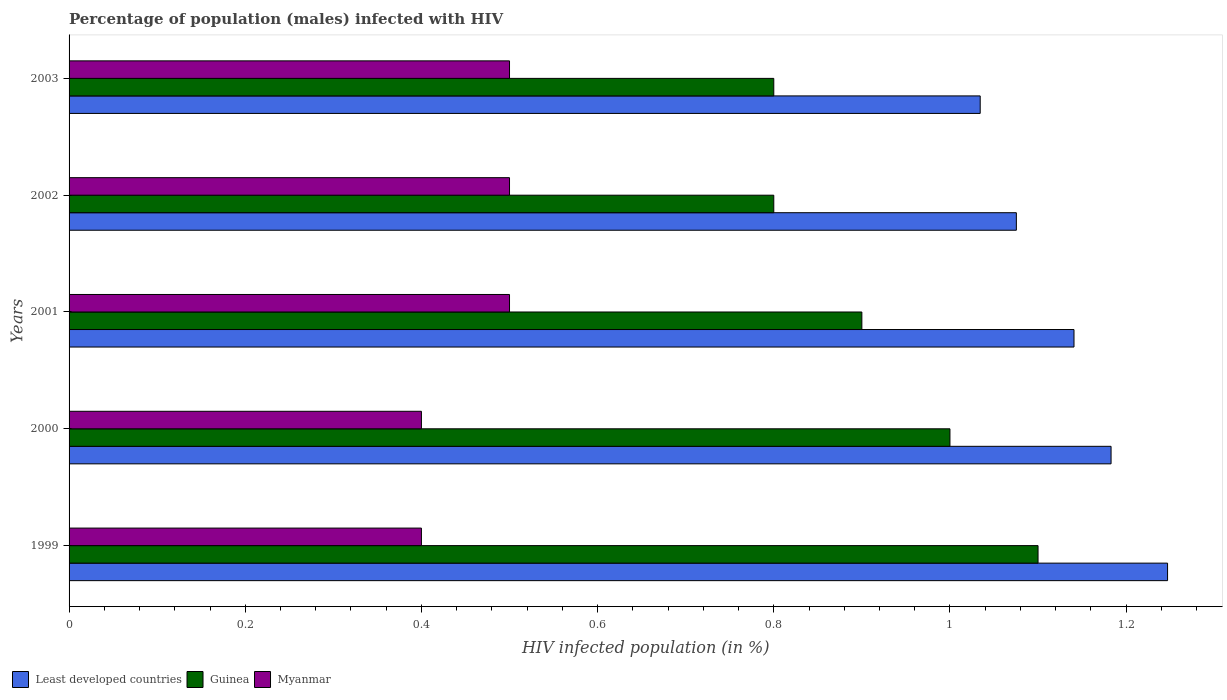Are the number of bars on each tick of the Y-axis equal?
Ensure brevity in your answer.  Yes. How many bars are there on the 2nd tick from the top?
Keep it short and to the point. 3. How many bars are there on the 4th tick from the bottom?
Give a very brief answer. 3. What is the label of the 2nd group of bars from the top?
Provide a short and direct response. 2002. What is the percentage of HIV infected male population in Least developed countries in 2000?
Your answer should be compact. 1.18. Across all years, what is the maximum percentage of HIV infected male population in Myanmar?
Ensure brevity in your answer.  0.5. What is the difference between the percentage of HIV infected male population in Least developed countries in 2002 and that in 2003?
Give a very brief answer. 0.04. What is the difference between the percentage of HIV infected male population in Myanmar in 2000 and the percentage of HIV infected male population in Guinea in 1999?
Offer a terse response. -0.7. What is the average percentage of HIV infected male population in Guinea per year?
Your response must be concise. 0.92. In the year 2002, what is the difference between the percentage of HIV infected male population in Myanmar and percentage of HIV infected male population in Guinea?
Your answer should be very brief. -0.3. What is the ratio of the percentage of HIV infected male population in Myanmar in 1999 to that in 2000?
Offer a very short reply. 1. What is the difference between the highest and the second highest percentage of HIV infected male population in Guinea?
Ensure brevity in your answer.  0.1. What is the difference between the highest and the lowest percentage of HIV infected male population in Guinea?
Offer a very short reply. 0.3. In how many years, is the percentage of HIV infected male population in Least developed countries greater than the average percentage of HIV infected male population in Least developed countries taken over all years?
Offer a very short reply. 3. Is the sum of the percentage of HIV infected male population in Least developed countries in 2000 and 2003 greater than the maximum percentage of HIV infected male population in Guinea across all years?
Make the answer very short. Yes. What does the 3rd bar from the top in 2003 represents?
Your response must be concise. Least developed countries. What does the 2nd bar from the bottom in 2003 represents?
Make the answer very short. Guinea. Is it the case that in every year, the sum of the percentage of HIV infected male population in Guinea and percentage of HIV infected male population in Least developed countries is greater than the percentage of HIV infected male population in Myanmar?
Offer a terse response. Yes. Are all the bars in the graph horizontal?
Keep it short and to the point. Yes. How many years are there in the graph?
Your answer should be very brief. 5. What is the difference between two consecutive major ticks on the X-axis?
Ensure brevity in your answer.  0.2. Are the values on the major ticks of X-axis written in scientific E-notation?
Offer a terse response. No. How are the legend labels stacked?
Make the answer very short. Horizontal. What is the title of the graph?
Your response must be concise. Percentage of population (males) infected with HIV. Does "Russian Federation" appear as one of the legend labels in the graph?
Provide a short and direct response. No. What is the label or title of the X-axis?
Offer a terse response. HIV infected population (in %). What is the HIV infected population (in %) of Least developed countries in 1999?
Give a very brief answer. 1.25. What is the HIV infected population (in %) of Guinea in 1999?
Give a very brief answer. 1.1. What is the HIV infected population (in %) in Least developed countries in 2000?
Make the answer very short. 1.18. What is the HIV infected population (in %) in Guinea in 2000?
Offer a terse response. 1. What is the HIV infected population (in %) of Least developed countries in 2001?
Your answer should be very brief. 1.14. What is the HIV infected population (in %) in Guinea in 2001?
Offer a very short reply. 0.9. What is the HIV infected population (in %) of Myanmar in 2001?
Provide a short and direct response. 0.5. What is the HIV infected population (in %) of Least developed countries in 2002?
Your answer should be compact. 1.08. What is the HIV infected population (in %) in Guinea in 2002?
Provide a succinct answer. 0.8. What is the HIV infected population (in %) in Least developed countries in 2003?
Ensure brevity in your answer.  1.03. Across all years, what is the maximum HIV infected population (in %) of Least developed countries?
Offer a terse response. 1.25. Across all years, what is the maximum HIV infected population (in %) in Guinea?
Give a very brief answer. 1.1. Across all years, what is the minimum HIV infected population (in %) in Least developed countries?
Your answer should be very brief. 1.03. Across all years, what is the minimum HIV infected population (in %) in Myanmar?
Provide a short and direct response. 0.4. What is the total HIV infected population (in %) of Least developed countries in the graph?
Give a very brief answer. 5.68. What is the total HIV infected population (in %) of Myanmar in the graph?
Keep it short and to the point. 2.3. What is the difference between the HIV infected population (in %) of Least developed countries in 1999 and that in 2000?
Offer a terse response. 0.06. What is the difference between the HIV infected population (in %) of Least developed countries in 1999 and that in 2001?
Make the answer very short. 0.11. What is the difference between the HIV infected population (in %) in Guinea in 1999 and that in 2001?
Give a very brief answer. 0.2. What is the difference between the HIV infected population (in %) of Myanmar in 1999 and that in 2001?
Your response must be concise. -0.1. What is the difference between the HIV infected population (in %) in Least developed countries in 1999 and that in 2002?
Offer a terse response. 0.17. What is the difference between the HIV infected population (in %) of Least developed countries in 1999 and that in 2003?
Provide a short and direct response. 0.21. What is the difference between the HIV infected population (in %) of Guinea in 1999 and that in 2003?
Provide a succinct answer. 0.3. What is the difference between the HIV infected population (in %) of Least developed countries in 2000 and that in 2001?
Your response must be concise. 0.04. What is the difference between the HIV infected population (in %) of Myanmar in 2000 and that in 2001?
Keep it short and to the point. -0.1. What is the difference between the HIV infected population (in %) in Least developed countries in 2000 and that in 2002?
Ensure brevity in your answer.  0.11. What is the difference between the HIV infected population (in %) of Least developed countries in 2000 and that in 2003?
Offer a terse response. 0.15. What is the difference between the HIV infected population (in %) of Guinea in 2000 and that in 2003?
Offer a terse response. 0.2. What is the difference between the HIV infected population (in %) in Least developed countries in 2001 and that in 2002?
Provide a short and direct response. 0.07. What is the difference between the HIV infected population (in %) of Guinea in 2001 and that in 2002?
Offer a terse response. 0.1. What is the difference between the HIV infected population (in %) in Myanmar in 2001 and that in 2002?
Give a very brief answer. 0. What is the difference between the HIV infected population (in %) in Least developed countries in 2001 and that in 2003?
Make the answer very short. 0.11. What is the difference between the HIV infected population (in %) in Guinea in 2001 and that in 2003?
Offer a very short reply. 0.1. What is the difference between the HIV infected population (in %) in Myanmar in 2001 and that in 2003?
Your answer should be compact. 0. What is the difference between the HIV infected population (in %) of Least developed countries in 2002 and that in 2003?
Your answer should be very brief. 0.04. What is the difference between the HIV infected population (in %) of Myanmar in 2002 and that in 2003?
Your answer should be very brief. 0. What is the difference between the HIV infected population (in %) of Least developed countries in 1999 and the HIV infected population (in %) of Guinea in 2000?
Your answer should be very brief. 0.25. What is the difference between the HIV infected population (in %) in Least developed countries in 1999 and the HIV infected population (in %) in Myanmar in 2000?
Offer a very short reply. 0.85. What is the difference between the HIV infected population (in %) in Guinea in 1999 and the HIV infected population (in %) in Myanmar in 2000?
Offer a terse response. 0.7. What is the difference between the HIV infected population (in %) in Least developed countries in 1999 and the HIV infected population (in %) in Guinea in 2001?
Offer a terse response. 0.35. What is the difference between the HIV infected population (in %) of Least developed countries in 1999 and the HIV infected population (in %) of Myanmar in 2001?
Provide a succinct answer. 0.75. What is the difference between the HIV infected population (in %) in Guinea in 1999 and the HIV infected population (in %) in Myanmar in 2001?
Make the answer very short. 0.6. What is the difference between the HIV infected population (in %) of Least developed countries in 1999 and the HIV infected population (in %) of Guinea in 2002?
Keep it short and to the point. 0.45. What is the difference between the HIV infected population (in %) of Least developed countries in 1999 and the HIV infected population (in %) of Myanmar in 2002?
Keep it short and to the point. 0.75. What is the difference between the HIV infected population (in %) of Least developed countries in 1999 and the HIV infected population (in %) of Guinea in 2003?
Give a very brief answer. 0.45. What is the difference between the HIV infected population (in %) in Least developed countries in 1999 and the HIV infected population (in %) in Myanmar in 2003?
Your answer should be compact. 0.75. What is the difference between the HIV infected population (in %) in Guinea in 1999 and the HIV infected population (in %) in Myanmar in 2003?
Provide a succinct answer. 0.6. What is the difference between the HIV infected population (in %) of Least developed countries in 2000 and the HIV infected population (in %) of Guinea in 2001?
Offer a very short reply. 0.28. What is the difference between the HIV infected population (in %) in Least developed countries in 2000 and the HIV infected population (in %) in Myanmar in 2001?
Your answer should be compact. 0.68. What is the difference between the HIV infected population (in %) in Guinea in 2000 and the HIV infected population (in %) in Myanmar in 2001?
Offer a terse response. 0.5. What is the difference between the HIV infected population (in %) in Least developed countries in 2000 and the HIV infected population (in %) in Guinea in 2002?
Ensure brevity in your answer.  0.38. What is the difference between the HIV infected population (in %) of Least developed countries in 2000 and the HIV infected population (in %) of Myanmar in 2002?
Offer a very short reply. 0.68. What is the difference between the HIV infected population (in %) in Least developed countries in 2000 and the HIV infected population (in %) in Guinea in 2003?
Make the answer very short. 0.38. What is the difference between the HIV infected population (in %) of Least developed countries in 2000 and the HIV infected population (in %) of Myanmar in 2003?
Provide a short and direct response. 0.68. What is the difference between the HIV infected population (in %) in Guinea in 2000 and the HIV infected population (in %) in Myanmar in 2003?
Offer a terse response. 0.5. What is the difference between the HIV infected population (in %) in Least developed countries in 2001 and the HIV infected population (in %) in Guinea in 2002?
Offer a terse response. 0.34. What is the difference between the HIV infected population (in %) in Least developed countries in 2001 and the HIV infected population (in %) in Myanmar in 2002?
Keep it short and to the point. 0.64. What is the difference between the HIV infected population (in %) in Least developed countries in 2001 and the HIV infected population (in %) in Guinea in 2003?
Provide a short and direct response. 0.34. What is the difference between the HIV infected population (in %) in Least developed countries in 2001 and the HIV infected population (in %) in Myanmar in 2003?
Keep it short and to the point. 0.64. What is the difference between the HIV infected population (in %) in Guinea in 2001 and the HIV infected population (in %) in Myanmar in 2003?
Your response must be concise. 0.4. What is the difference between the HIV infected population (in %) of Least developed countries in 2002 and the HIV infected population (in %) of Guinea in 2003?
Keep it short and to the point. 0.28. What is the difference between the HIV infected population (in %) of Least developed countries in 2002 and the HIV infected population (in %) of Myanmar in 2003?
Give a very brief answer. 0.58. What is the difference between the HIV infected population (in %) in Guinea in 2002 and the HIV infected population (in %) in Myanmar in 2003?
Give a very brief answer. 0.3. What is the average HIV infected population (in %) of Least developed countries per year?
Provide a short and direct response. 1.14. What is the average HIV infected population (in %) of Myanmar per year?
Offer a very short reply. 0.46. In the year 1999, what is the difference between the HIV infected population (in %) in Least developed countries and HIV infected population (in %) in Guinea?
Your response must be concise. 0.15. In the year 1999, what is the difference between the HIV infected population (in %) of Least developed countries and HIV infected population (in %) of Myanmar?
Keep it short and to the point. 0.85. In the year 2000, what is the difference between the HIV infected population (in %) of Least developed countries and HIV infected population (in %) of Guinea?
Keep it short and to the point. 0.18. In the year 2000, what is the difference between the HIV infected population (in %) of Least developed countries and HIV infected population (in %) of Myanmar?
Provide a succinct answer. 0.78. In the year 2000, what is the difference between the HIV infected population (in %) in Guinea and HIV infected population (in %) in Myanmar?
Provide a succinct answer. 0.6. In the year 2001, what is the difference between the HIV infected population (in %) of Least developed countries and HIV infected population (in %) of Guinea?
Give a very brief answer. 0.24. In the year 2001, what is the difference between the HIV infected population (in %) in Least developed countries and HIV infected population (in %) in Myanmar?
Your answer should be very brief. 0.64. In the year 2002, what is the difference between the HIV infected population (in %) of Least developed countries and HIV infected population (in %) of Guinea?
Offer a very short reply. 0.28. In the year 2002, what is the difference between the HIV infected population (in %) of Least developed countries and HIV infected population (in %) of Myanmar?
Provide a succinct answer. 0.58. In the year 2002, what is the difference between the HIV infected population (in %) in Guinea and HIV infected population (in %) in Myanmar?
Provide a succinct answer. 0.3. In the year 2003, what is the difference between the HIV infected population (in %) of Least developed countries and HIV infected population (in %) of Guinea?
Offer a very short reply. 0.23. In the year 2003, what is the difference between the HIV infected population (in %) of Least developed countries and HIV infected population (in %) of Myanmar?
Offer a very short reply. 0.53. In the year 2003, what is the difference between the HIV infected population (in %) in Guinea and HIV infected population (in %) in Myanmar?
Your response must be concise. 0.3. What is the ratio of the HIV infected population (in %) in Least developed countries in 1999 to that in 2000?
Make the answer very short. 1.05. What is the ratio of the HIV infected population (in %) in Guinea in 1999 to that in 2000?
Give a very brief answer. 1.1. What is the ratio of the HIV infected population (in %) of Least developed countries in 1999 to that in 2001?
Your response must be concise. 1.09. What is the ratio of the HIV infected population (in %) in Guinea in 1999 to that in 2001?
Provide a succinct answer. 1.22. What is the ratio of the HIV infected population (in %) in Least developed countries in 1999 to that in 2002?
Provide a succinct answer. 1.16. What is the ratio of the HIV infected population (in %) of Guinea in 1999 to that in 2002?
Offer a terse response. 1.38. What is the ratio of the HIV infected population (in %) in Myanmar in 1999 to that in 2002?
Give a very brief answer. 0.8. What is the ratio of the HIV infected population (in %) in Least developed countries in 1999 to that in 2003?
Make the answer very short. 1.21. What is the ratio of the HIV infected population (in %) of Guinea in 1999 to that in 2003?
Ensure brevity in your answer.  1.38. What is the ratio of the HIV infected population (in %) of Myanmar in 1999 to that in 2003?
Your answer should be very brief. 0.8. What is the ratio of the HIV infected population (in %) of Least developed countries in 2000 to that in 2001?
Ensure brevity in your answer.  1.04. What is the ratio of the HIV infected population (in %) in Guinea in 2000 to that in 2001?
Your answer should be very brief. 1.11. What is the ratio of the HIV infected population (in %) in Guinea in 2000 to that in 2002?
Ensure brevity in your answer.  1.25. What is the ratio of the HIV infected population (in %) of Myanmar in 2000 to that in 2002?
Provide a short and direct response. 0.8. What is the ratio of the HIV infected population (in %) of Least developed countries in 2000 to that in 2003?
Provide a succinct answer. 1.14. What is the ratio of the HIV infected population (in %) of Guinea in 2000 to that in 2003?
Give a very brief answer. 1.25. What is the ratio of the HIV infected population (in %) of Least developed countries in 2001 to that in 2002?
Your response must be concise. 1.06. What is the ratio of the HIV infected population (in %) of Guinea in 2001 to that in 2002?
Ensure brevity in your answer.  1.12. What is the ratio of the HIV infected population (in %) in Myanmar in 2001 to that in 2002?
Keep it short and to the point. 1. What is the ratio of the HIV infected population (in %) of Least developed countries in 2001 to that in 2003?
Your answer should be compact. 1.1. What is the ratio of the HIV infected population (in %) of Guinea in 2001 to that in 2003?
Provide a succinct answer. 1.12. What is the ratio of the HIV infected population (in %) of Least developed countries in 2002 to that in 2003?
Ensure brevity in your answer.  1.04. What is the ratio of the HIV infected population (in %) in Guinea in 2002 to that in 2003?
Ensure brevity in your answer.  1. What is the ratio of the HIV infected population (in %) in Myanmar in 2002 to that in 2003?
Offer a very short reply. 1. What is the difference between the highest and the second highest HIV infected population (in %) in Least developed countries?
Offer a terse response. 0.06. What is the difference between the highest and the second highest HIV infected population (in %) in Guinea?
Keep it short and to the point. 0.1. What is the difference between the highest and the second highest HIV infected population (in %) of Myanmar?
Keep it short and to the point. 0. What is the difference between the highest and the lowest HIV infected population (in %) of Least developed countries?
Give a very brief answer. 0.21. 